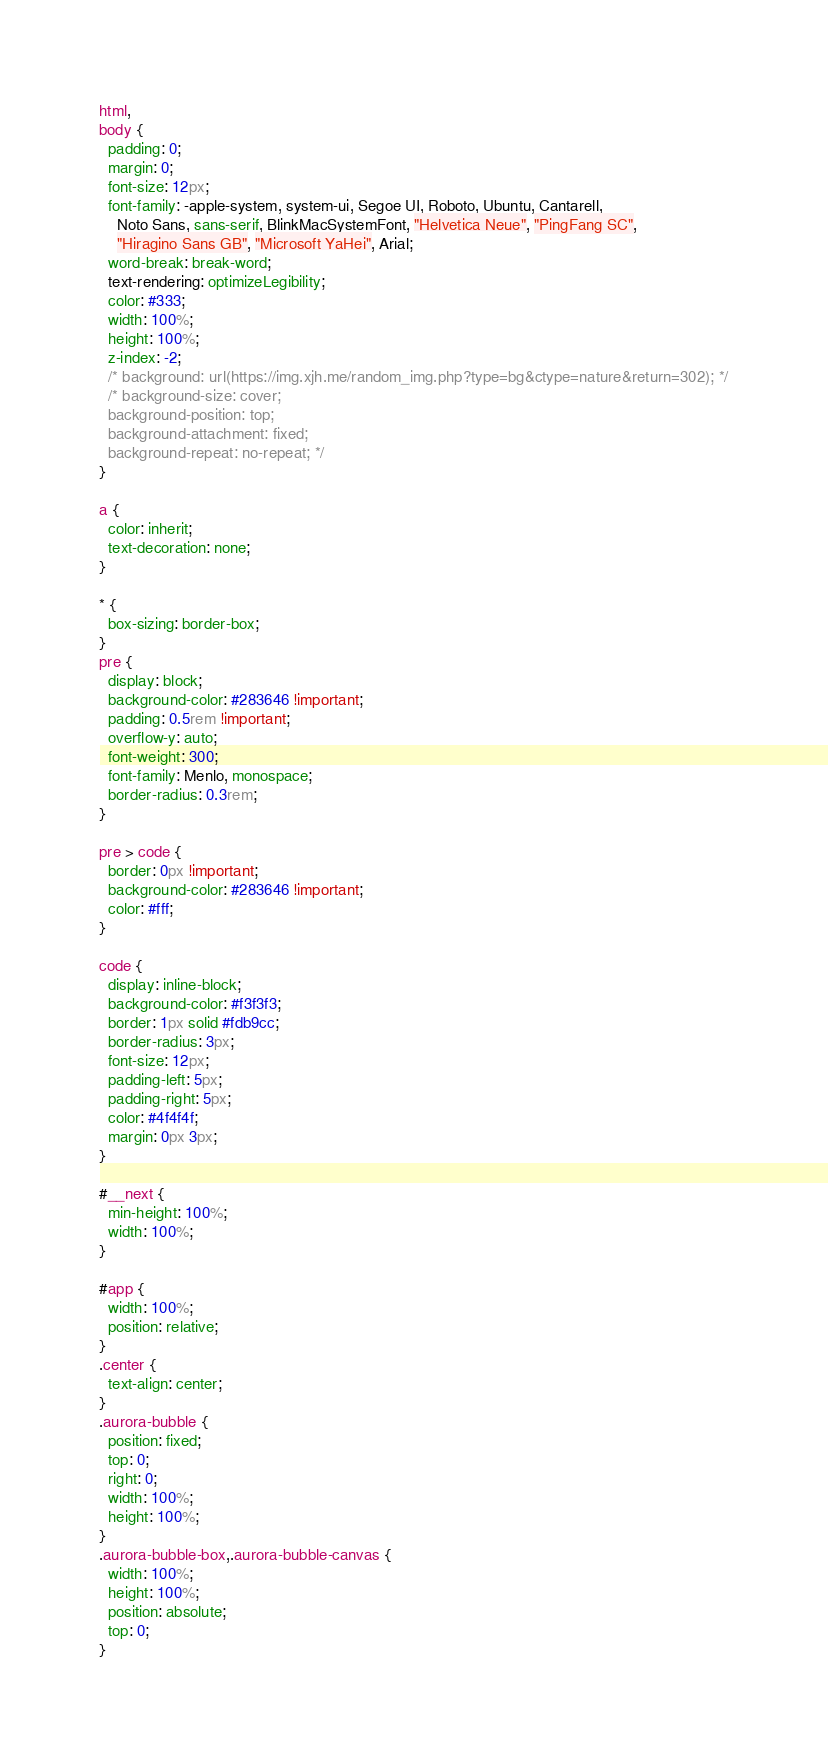Convert code to text. <code><loc_0><loc_0><loc_500><loc_500><_CSS_>html,
body {
  padding: 0;
  margin: 0;
  font-size: 12px;
  font-family: -apple-system, system-ui, Segoe UI, Roboto, Ubuntu, Cantarell,
    Noto Sans, sans-serif, BlinkMacSystemFont, "Helvetica Neue", "PingFang SC",
    "Hiragino Sans GB", "Microsoft YaHei", Arial;
  word-break: break-word;
  text-rendering: optimizeLegibility;
  color: #333;
  width: 100%;
  height: 100%;
  z-index: -2;
  /* background: url(https://img.xjh.me/random_img.php?type=bg&ctype=nature&return=302); */
  /* background-size: cover;
  background-position: top;
  background-attachment: fixed;
  background-repeat: no-repeat; */
}

a {
  color: inherit;
  text-decoration: none;
}

* {
  box-sizing: border-box;
}
pre {
  display: block;
  background-color: #283646 !important;
  padding: 0.5rem !important;
  overflow-y: auto;
  font-weight: 300;
  font-family: Menlo, monospace;
  border-radius: 0.3rem;
}

pre > code {
  border: 0px !important;
  background-color: #283646 !important;
  color: #fff;
}

code {
  display: inline-block;
  background-color: #f3f3f3;
  border: 1px solid #fdb9cc;
  border-radius: 3px;
  font-size: 12px;
  padding-left: 5px;
  padding-right: 5px;
  color: #4f4f4f;
  margin: 0px 3px;
}

#__next {
  min-height: 100%;
  width: 100%;
}

#app {
  width: 100%;
  position: relative;
}
.center {
  text-align: center;
}
.aurora-bubble {
  position: fixed;
  top: 0;
  right: 0;
  width: 100%;
  height: 100%;
}
.aurora-bubble-box,.aurora-bubble-canvas {
  width: 100%;
  height: 100%;
  position: absolute;
  top: 0;
}
</code> 